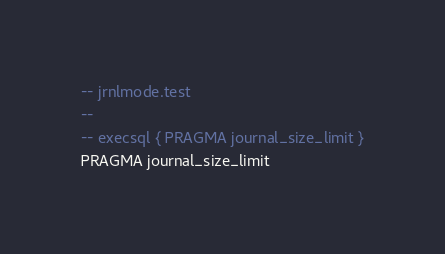<code> <loc_0><loc_0><loc_500><loc_500><_SQL_>-- jrnlmode.test
-- 
-- execsql { PRAGMA journal_size_limit }
PRAGMA journal_size_limit</code> 